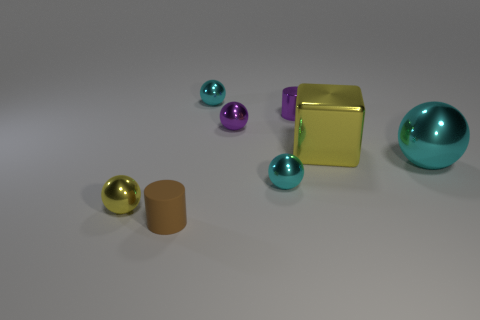How many cyan spheres must be subtracted to get 1 cyan spheres? 2 Subtract all red cubes. How many cyan spheres are left? 3 Subtract all purple balls. How many balls are left? 4 Subtract all yellow spheres. How many spheres are left? 4 Add 1 tiny matte things. How many objects exist? 9 Subtract all brown balls. Subtract all brown cylinders. How many balls are left? 5 Subtract all spheres. How many objects are left? 3 Add 4 matte things. How many matte things exist? 5 Subtract 1 yellow cubes. How many objects are left? 7 Subtract all tiny yellow balls. Subtract all small purple shiny cylinders. How many objects are left? 6 